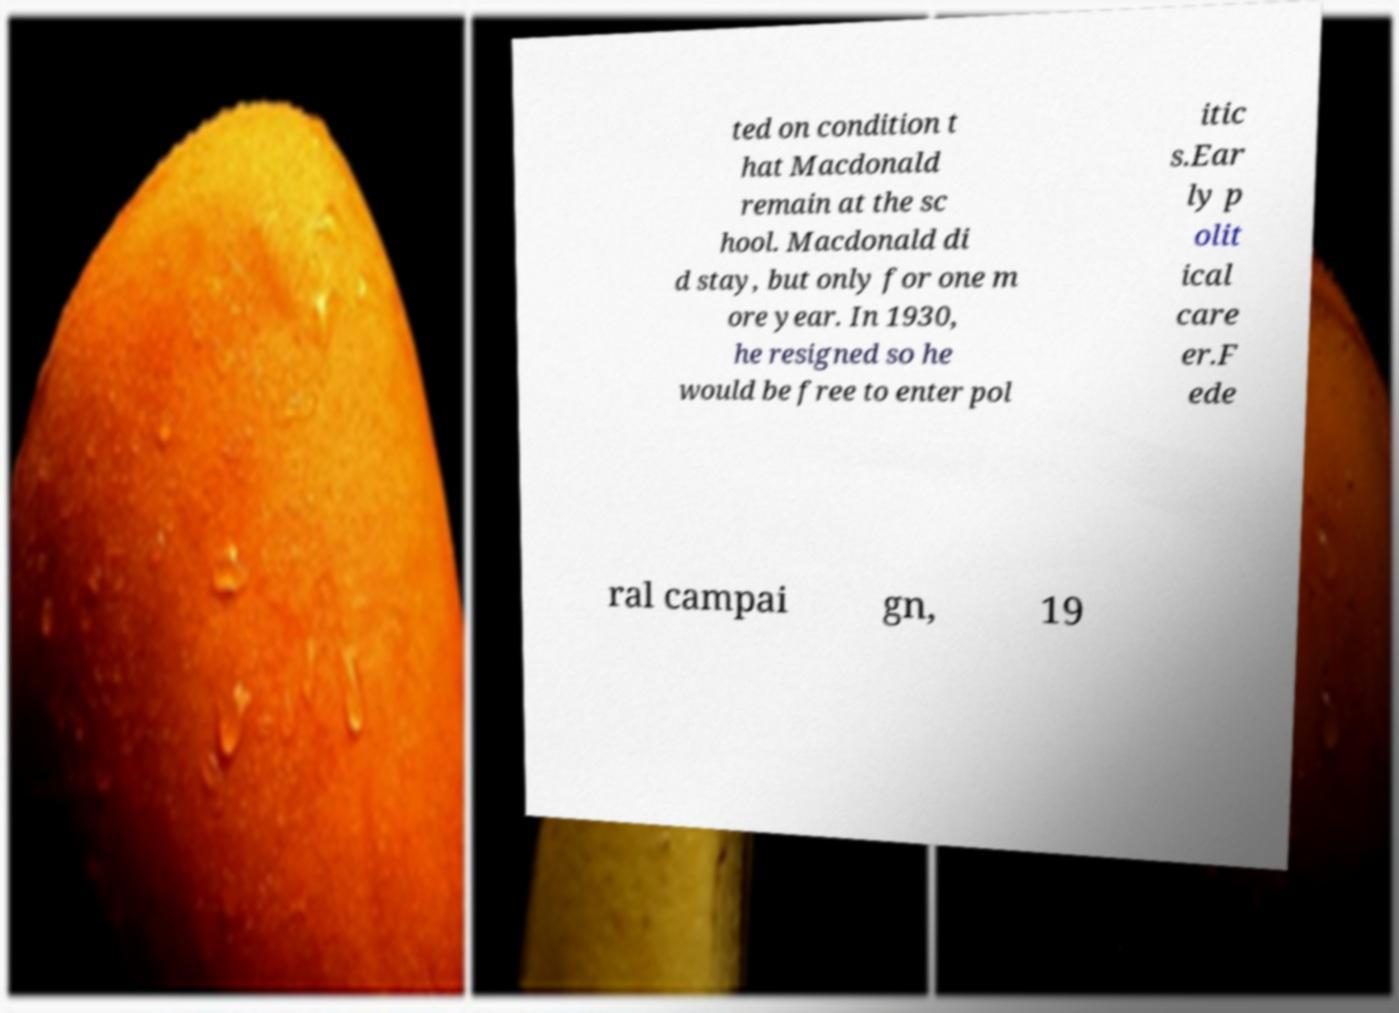Could you extract and type out the text from this image? ted on condition t hat Macdonald remain at the sc hool. Macdonald di d stay, but only for one m ore year. In 1930, he resigned so he would be free to enter pol itic s.Ear ly p olit ical care er.F ede ral campai gn, 19 